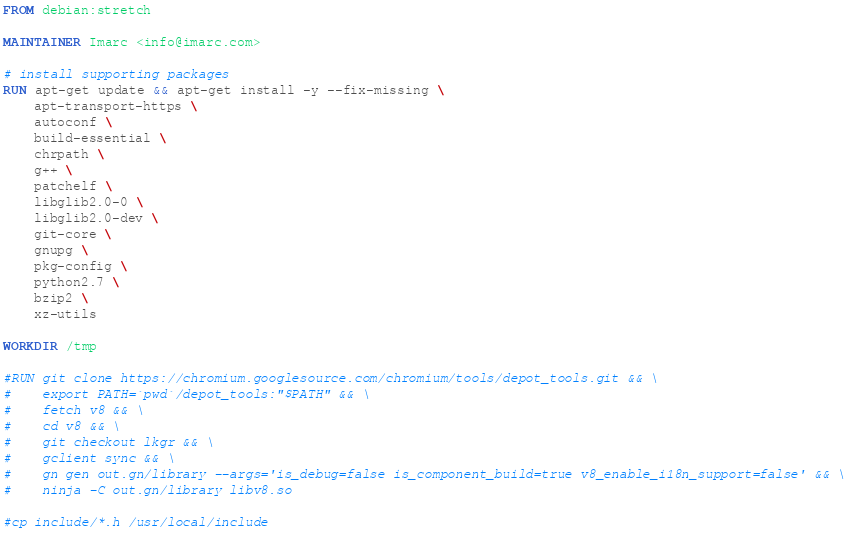<code> <loc_0><loc_0><loc_500><loc_500><_Dockerfile_>FROM debian:stretch

MAINTAINER Imarc <info@imarc.com>

# install supporting packages
RUN apt-get update && apt-get install -y --fix-missing \
    apt-transport-https \
    autoconf \
    build-essential \
    chrpath \
    g++ \
    patchelf \
    libglib2.0-0 \
    libglib2.0-dev \
    git-core \
    gnupg \
    pkg-config \
    python2.7 \
    bzip2 \
    xz-utils

WORKDIR /tmp

#RUN git clone https://chromium.googlesource.com/chromium/tools/depot_tools.git && \
#    export PATH=`pwd`/depot_tools:"$PATH" && \
#    fetch v8 && \
#    cd v8 && \
#    git checkout lkgr && \
#    gclient sync && \
#    gn gen out.gn/library --args='is_debug=false is_component_build=true v8_enable_i18n_support=false' && \
#    ninja -C out.gn/library libv8.so

#cp include/*.h /usr/local/include</code> 